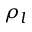Convert formula to latex. <formula><loc_0><loc_0><loc_500><loc_500>\rho _ { l }</formula> 